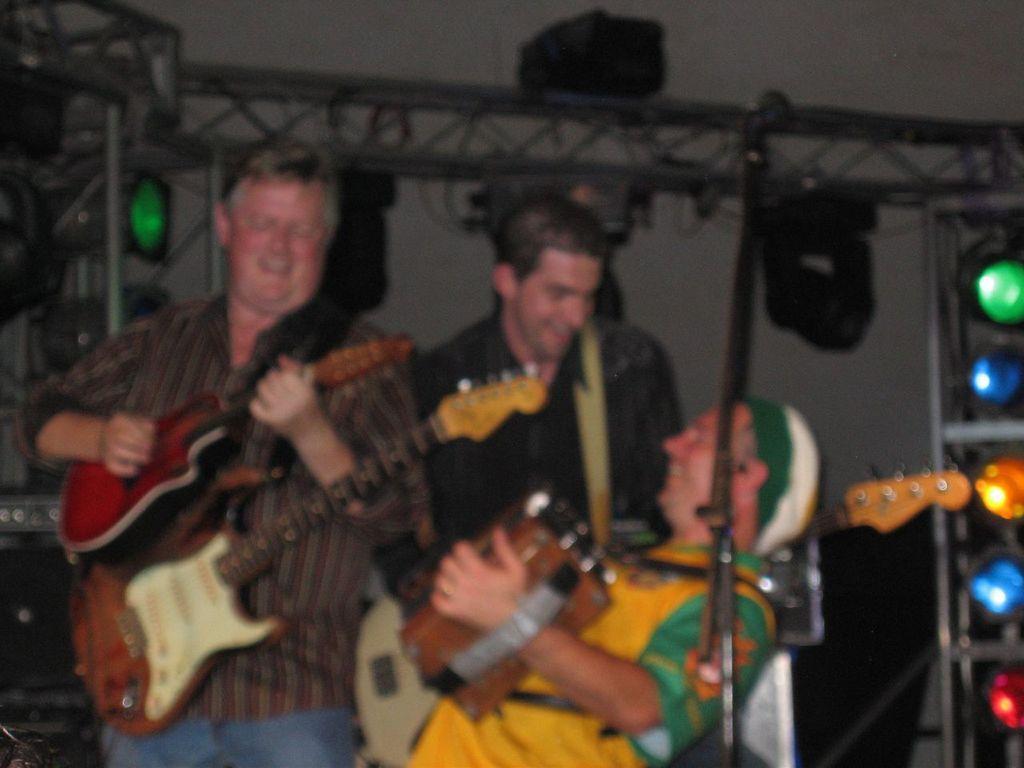Describe this image in one or two sentences. Here we can see three persons are playing guitar. In the background there is a wall and these are the lights. 